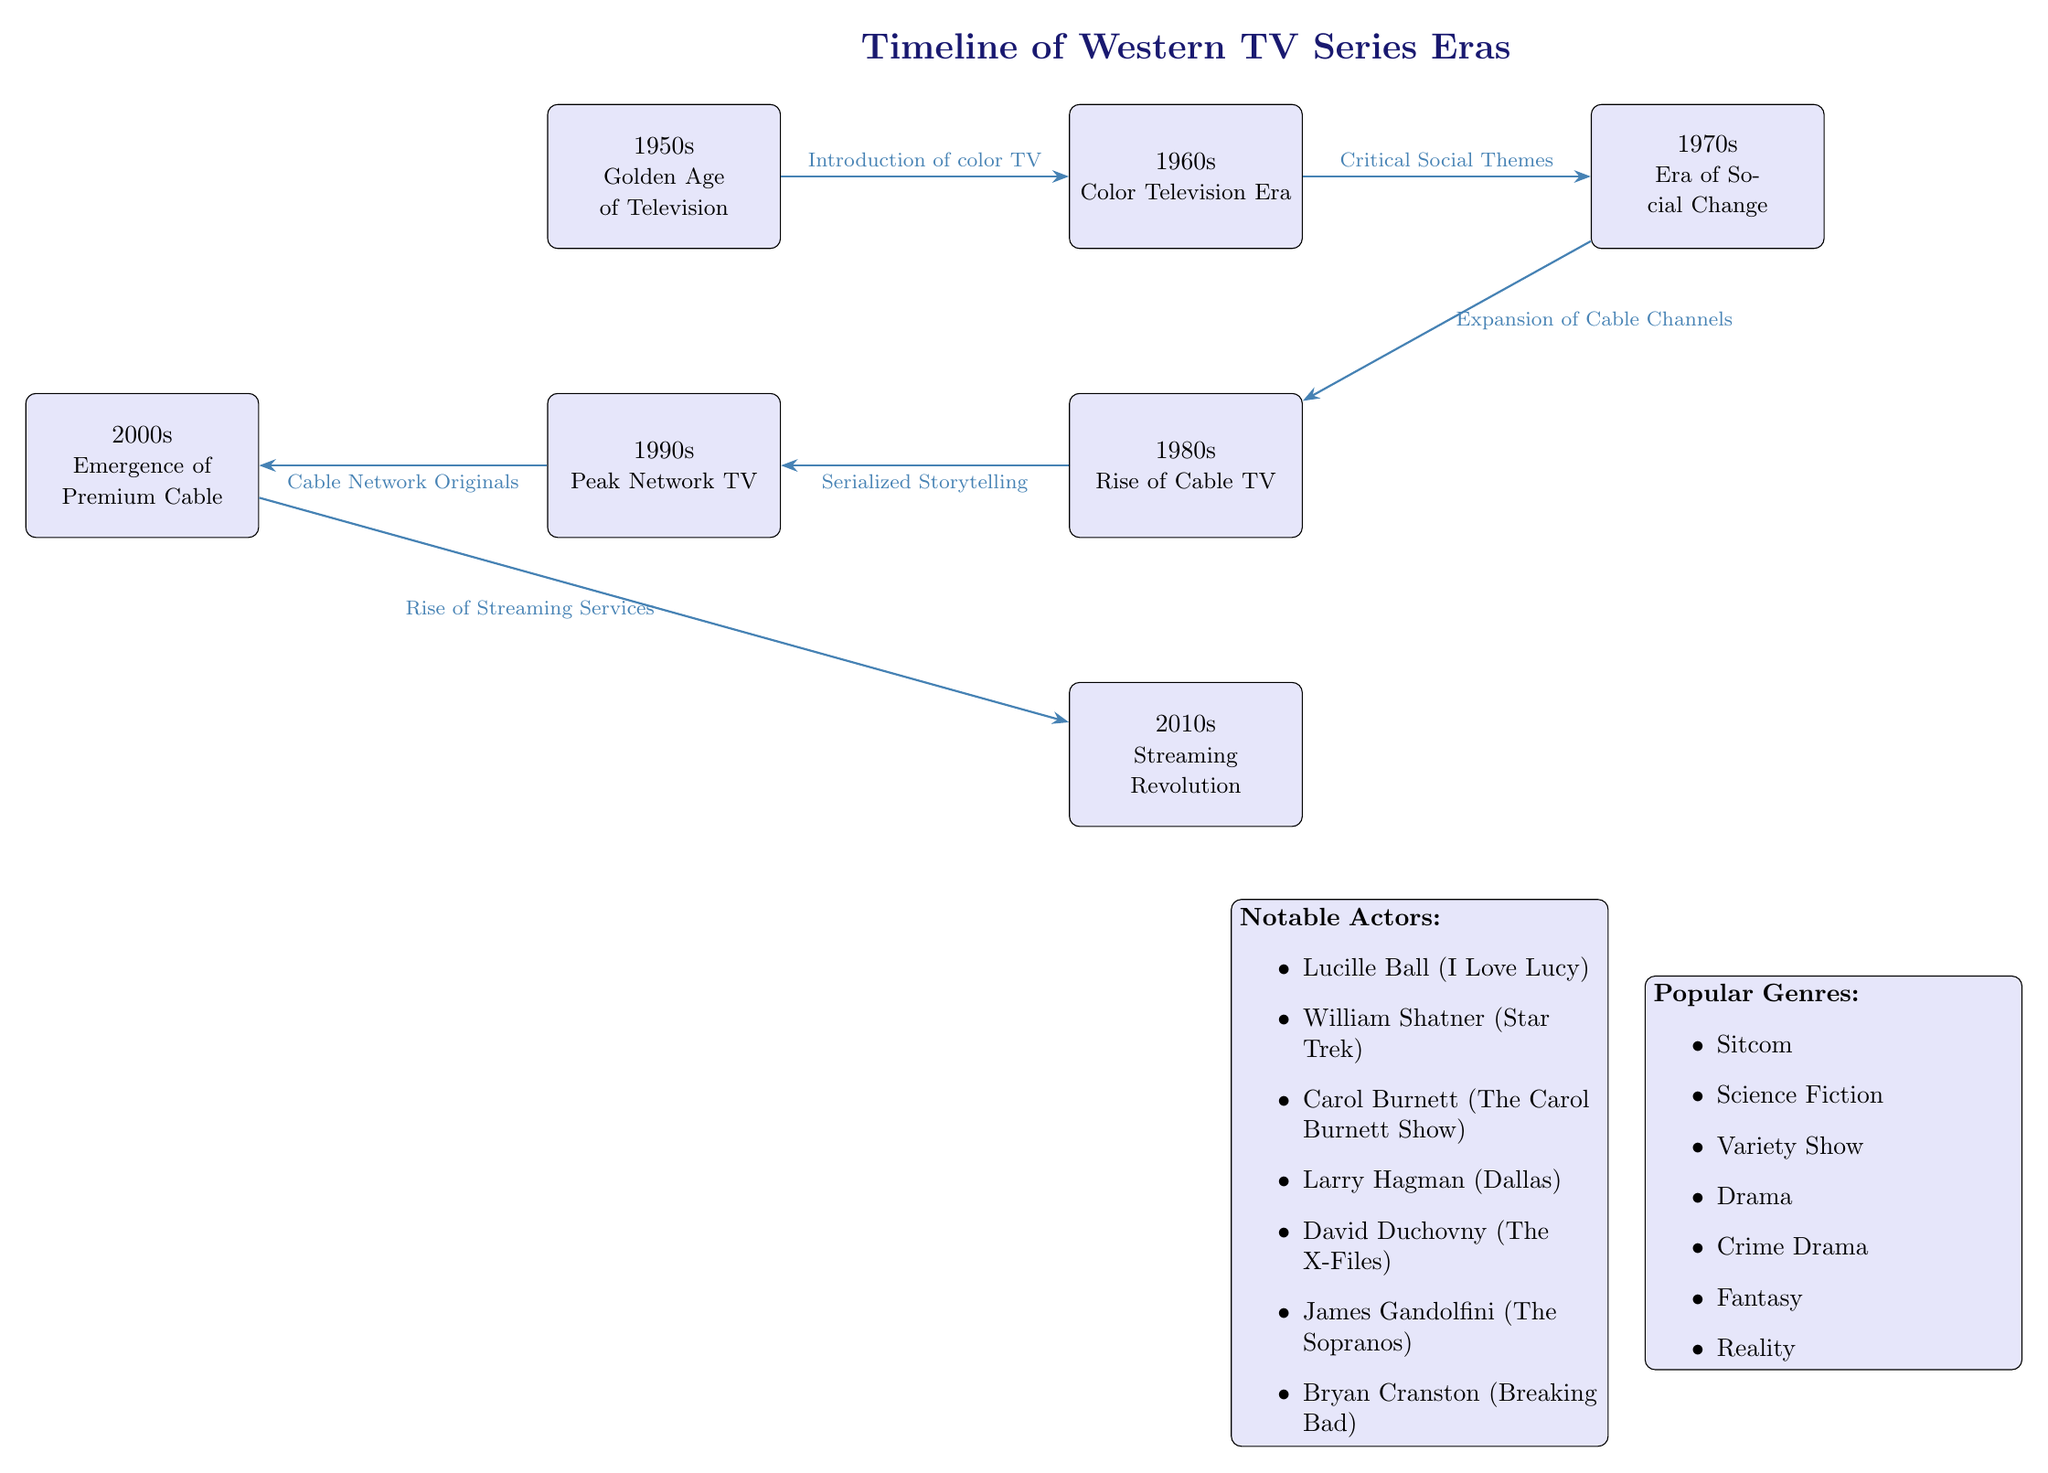What decade represents the Golden Age of Television? According to the diagram, the Golden Age of Television is represented in the 1950s node.
Answer: 1950s What significant development occurred in the 1960s era? The edge connecting the 1950s node to the 1960s node indicates the introduction of color TV as a significant development in the 1960s.
Answer: Introduction of color TV How many TV eras are represented in this diagram? By counting the nodes displayed, there are a total of six distinct TV eras shown in the diagram.
Answer: 6 What era follows the Era of Social Change? The diagram shows that the 1970s node is followed by the 1980s node, indicating that the Rise of Cable TV follows the Era of Social Change.
Answer: 1980s Which node has the highest emphasis on serialized storytelling? The arrow leading from the 1980s node to the 1990s node is labeled with "Serialized Storytelling," indicating it holds the most emphasis in that era.
Answer: 1990s Which TV era is associated with the term "Streaming Revolution"? The diagram shows that the Streaming Revolution is associated with the 2010s node, which is located at the bottom of the diagram.
Answer: 2010s What is the connection between the 2000s and the 2010s? The edge going from the 2000s node to the 2010s node specifies that the connection is the "Rise of Streaming Services."
Answer: Rise of Streaming Services Name a notable actor from the 2010s era. The actors node lists several notable actors, including Bryan Cranston, specifically linked to the era of the 2010s.
Answer: Bryan Cranston What genre was most commonly associated with the 1970s? While the diagram does not specify genres per decade, the 1970s era is known for critical social themes, which relate to drama and crime drama genres, as inferred from the common genres listed in the genres box.
Answer: Drama Which edge indicates the expansion of cable channels? The expansion of cable channels is indicated by the edge flowing from the 1970s node to the 1980s node, marking that transition.
Answer: Expansion of Cable Channels 